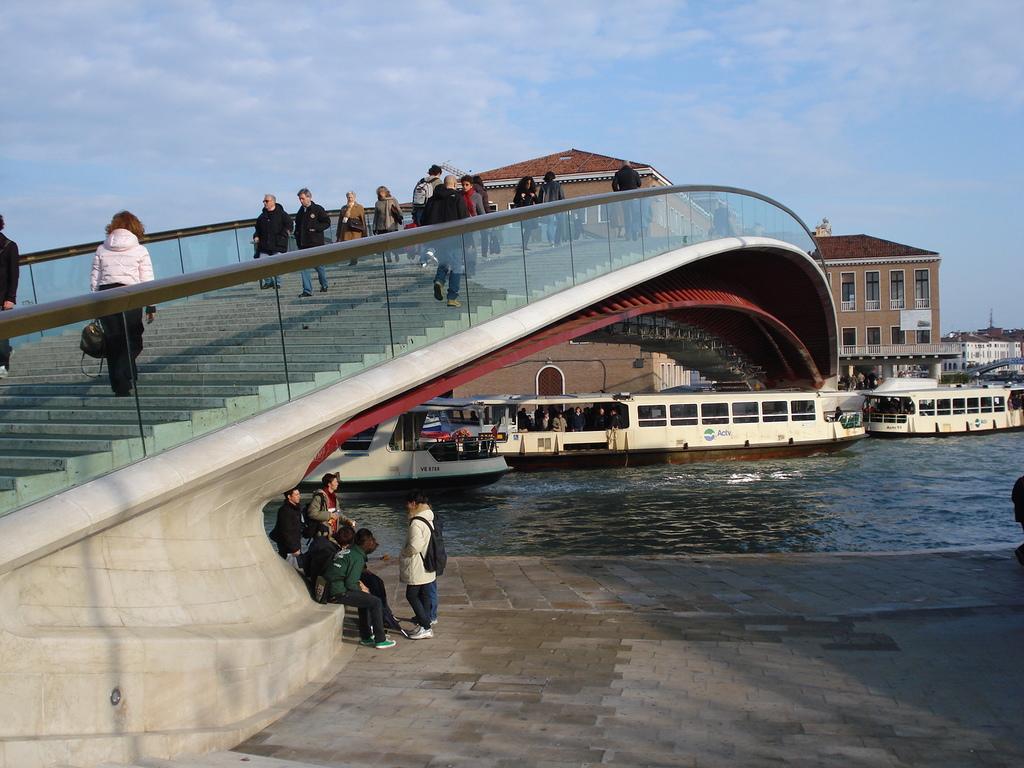In one or two sentences, can you explain what this image depicts? There are people on the stairs in the foreground and people at the bottom side, there are ships on the surface of water, houses and the sky in the background. 